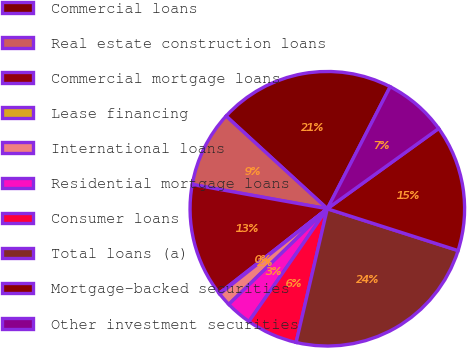Convert chart. <chart><loc_0><loc_0><loc_500><loc_500><pie_chart><fcel>Commercial loans<fcel>Real estate construction loans<fcel>Commercial mortgage loans<fcel>Lease financing<fcel>International loans<fcel>Residential mortgage loans<fcel>Consumer loans<fcel>Total loans (a)<fcel>Mortgage-backed securities<fcel>Other investment securities<nl><fcel>20.77%<fcel>8.97%<fcel>13.39%<fcel>0.11%<fcel>1.59%<fcel>3.07%<fcel>6.02%<fcel>23.72%<fcel>14.87%<fcel>7.49%<nl></chart> 